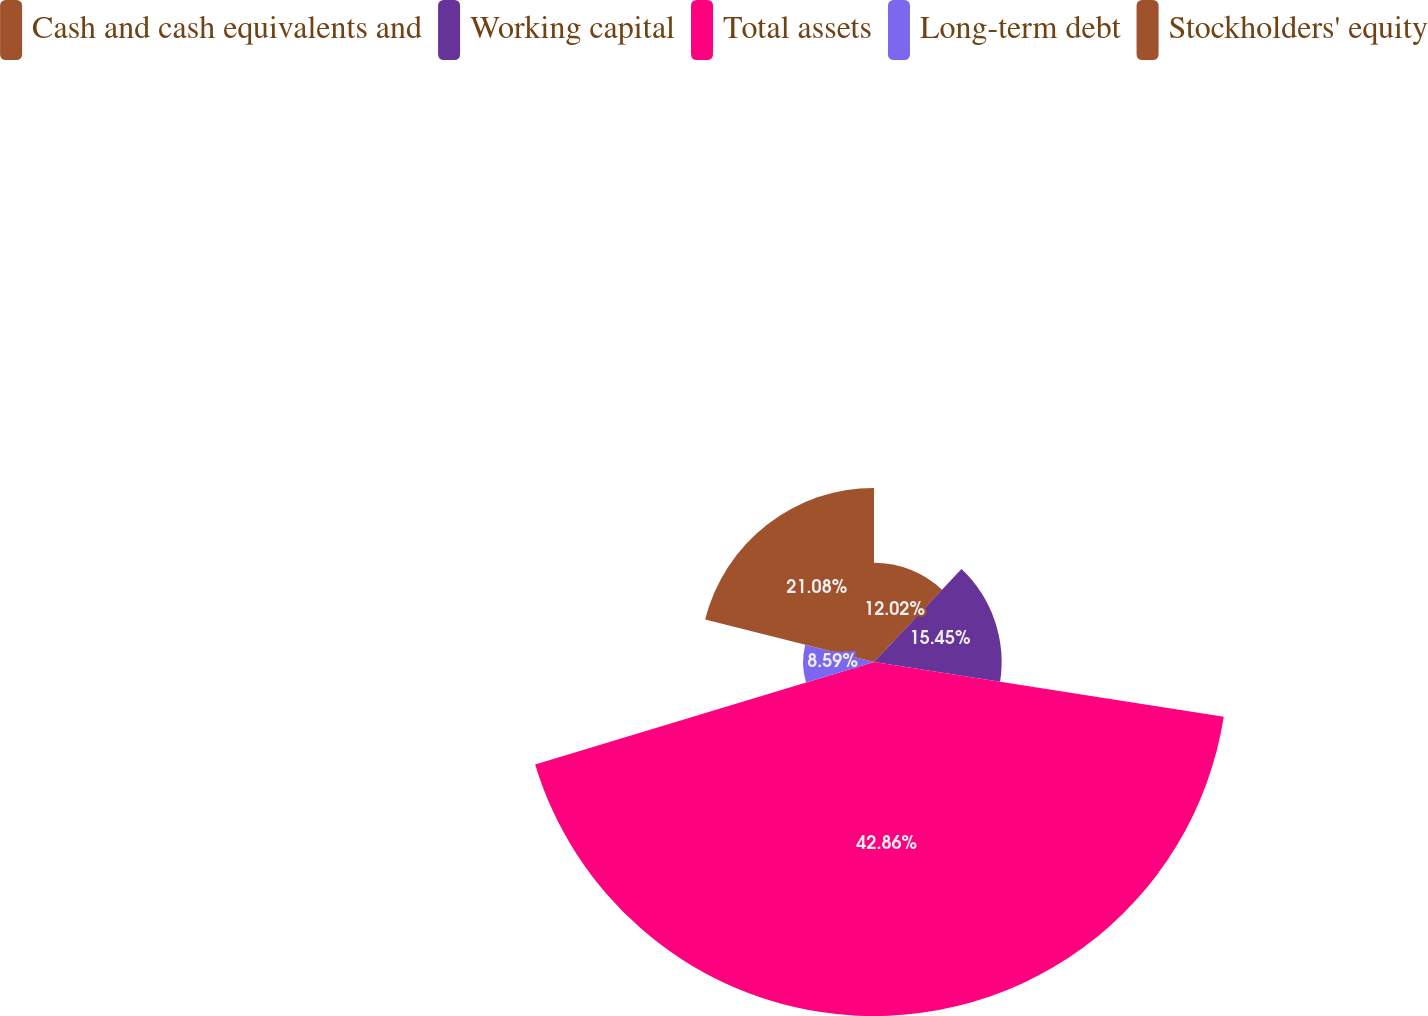<chart> <loc_0><loc_0><loc_500><loc_500><pie_chart><fcel>Cash and cash equivalents and<fcel>Working capital<fcel>Total assets<fcel>Long-term debt<fcel>Stockholders' equity<nl><fcel>12.02%<fcel>15.45%<fcel>42.86%<fcel>8.59%<fcel>21.08%<nl></chart> 